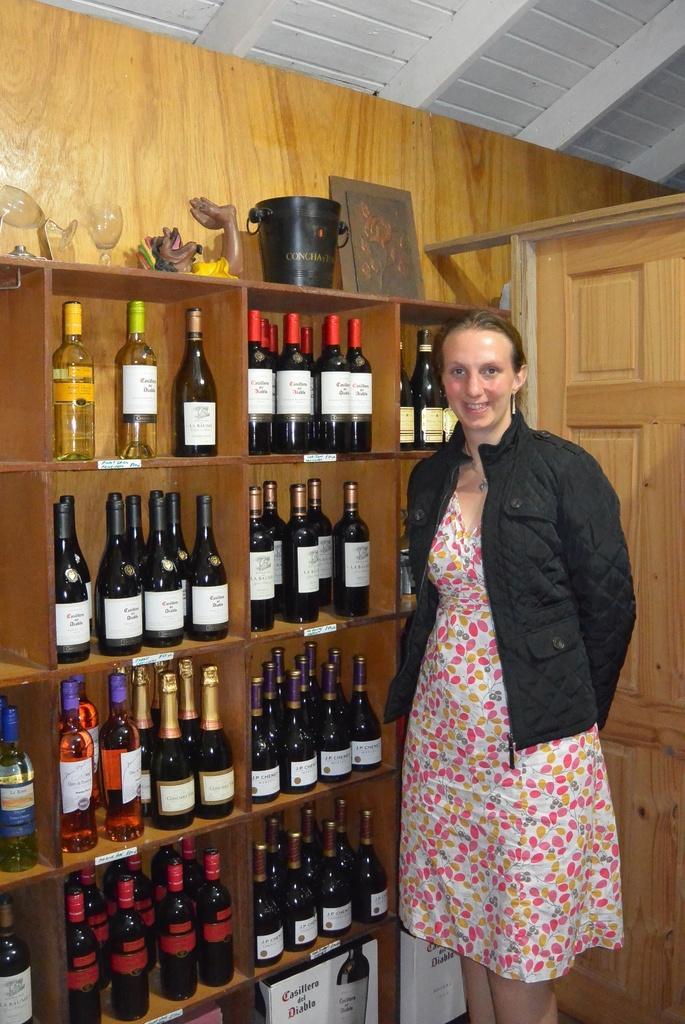Describe this image in one or two sentences. In the given image we can see a woman wearing a black color jacket is standing. This is a wooden shelf, bottle and wine glasses. 